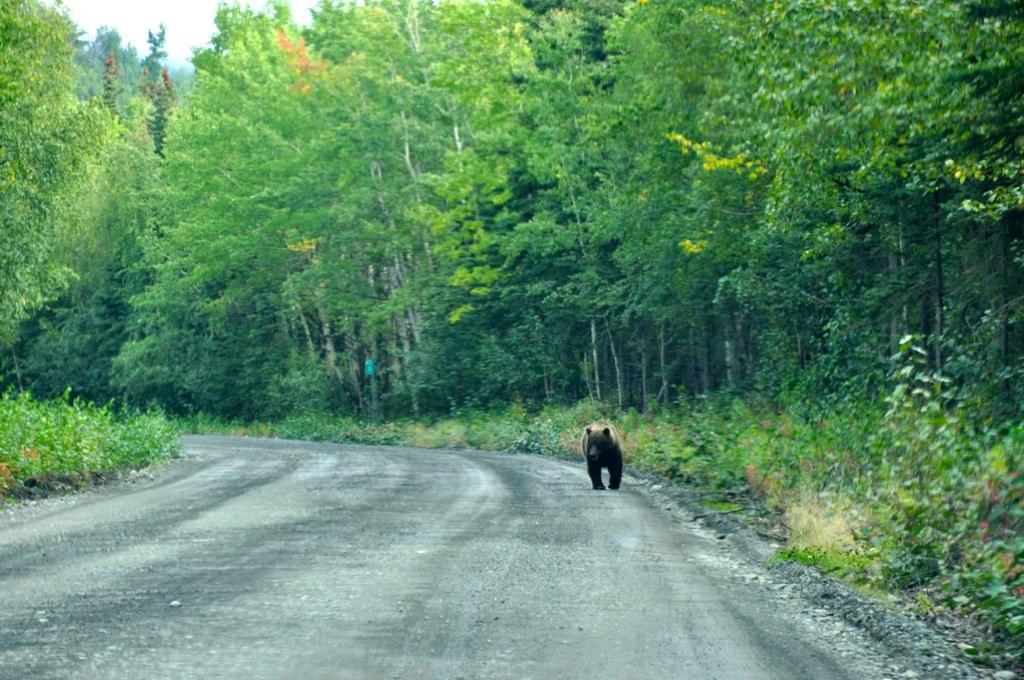Describe this image in one or two sentences. In this picture there is a bear standing on the road and there are trees on either sides of it. 